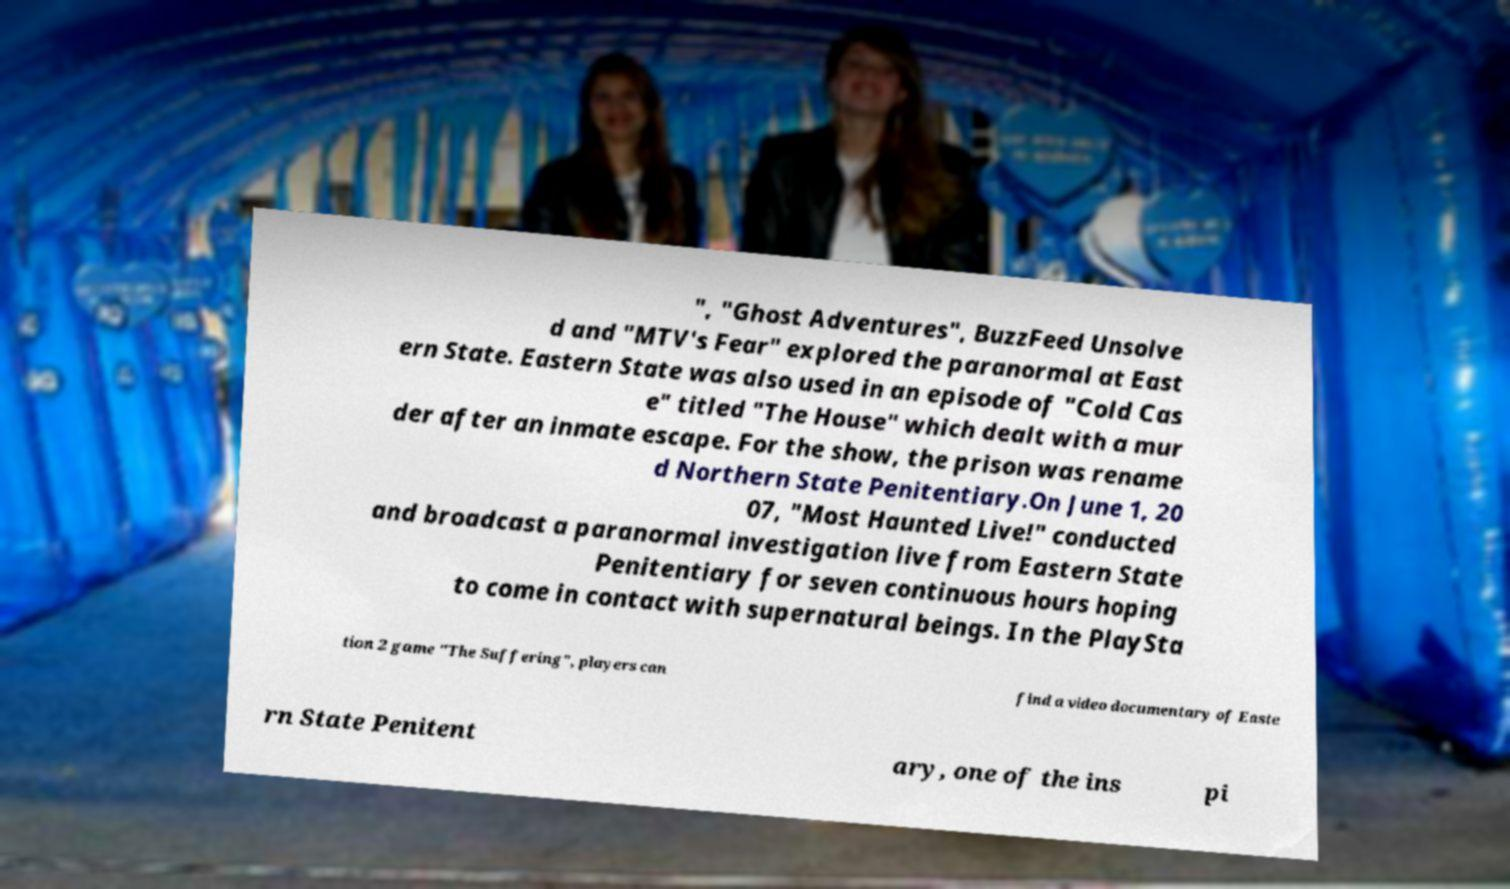Please read and relay the text visible in this image. What does it say? ", "Ghost Adventures", BuzzFeed Unsolve d and "MTV's Fear" explored the paranormal at East ern State. Eastern State was also used in an episode of "Cold Cas e" titled "The House" which dealt with a mur der after an inmate escape. For the show, the prison was rename d Northern State Penitentiary.On June 1, 20 07, "Most Haunted Live!" conducted and broadcast a paranormal investigation live from Eastern State Penitentiary for seven continuous hours hoping to come in contact with supernatural beings. In the PlaySta tion 2 game "The Suffering", players can find a video documentary of Easte rn State Penitent ary, one of the ins pi 